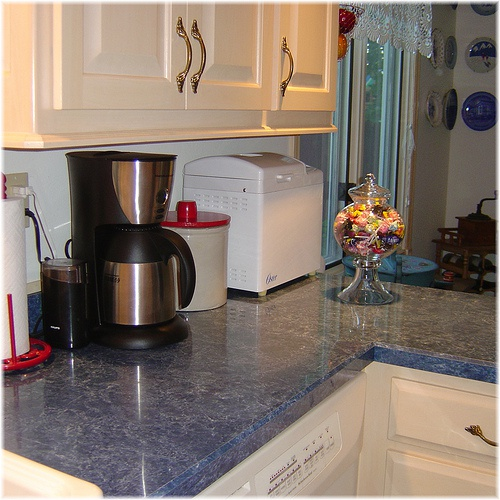Describe the objects in this image and their specific colors. I can see vase in white, gray, black, and maroon tones, sink in white, beige, tan, and gray tones, apple in white, maroon, black, and brown tones, and apple in white, maroon, and brown tones in this image. 